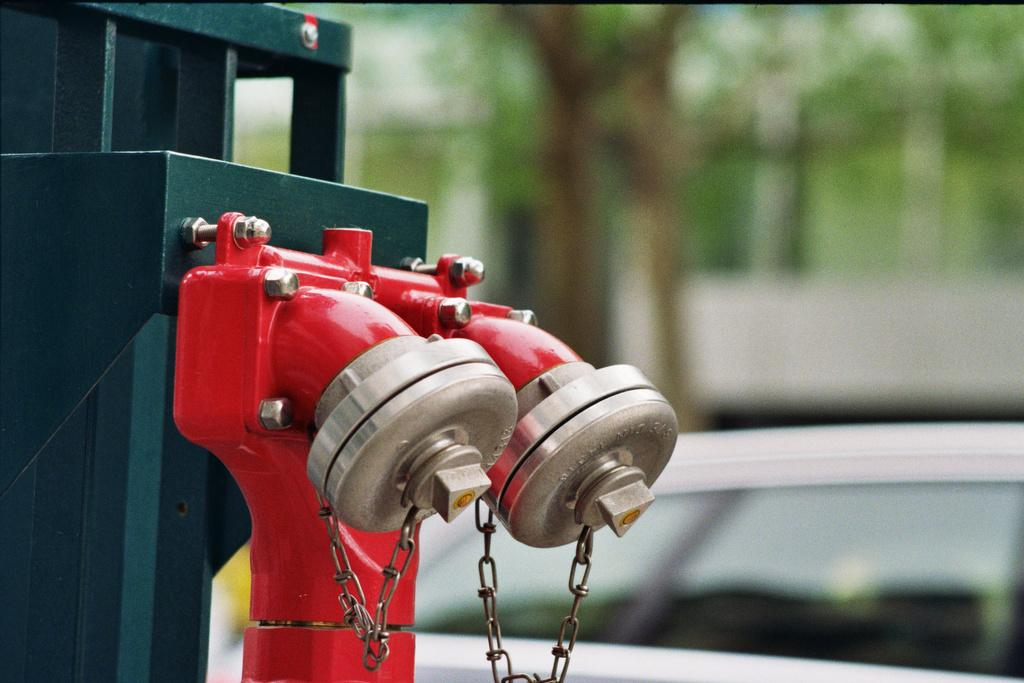What is the main subject in the middle of the image? There is a car in the middle of the image. What object can be seen on the left side of the image? There is a fire hydrant on the left side of the image. How would you describe the background of the image? The background of the image is blurry. How many brothers are present in the bedroom in the image? There is no bedroom or brothers present in the image; it features a car and a fire hydrant with a blurry background. 